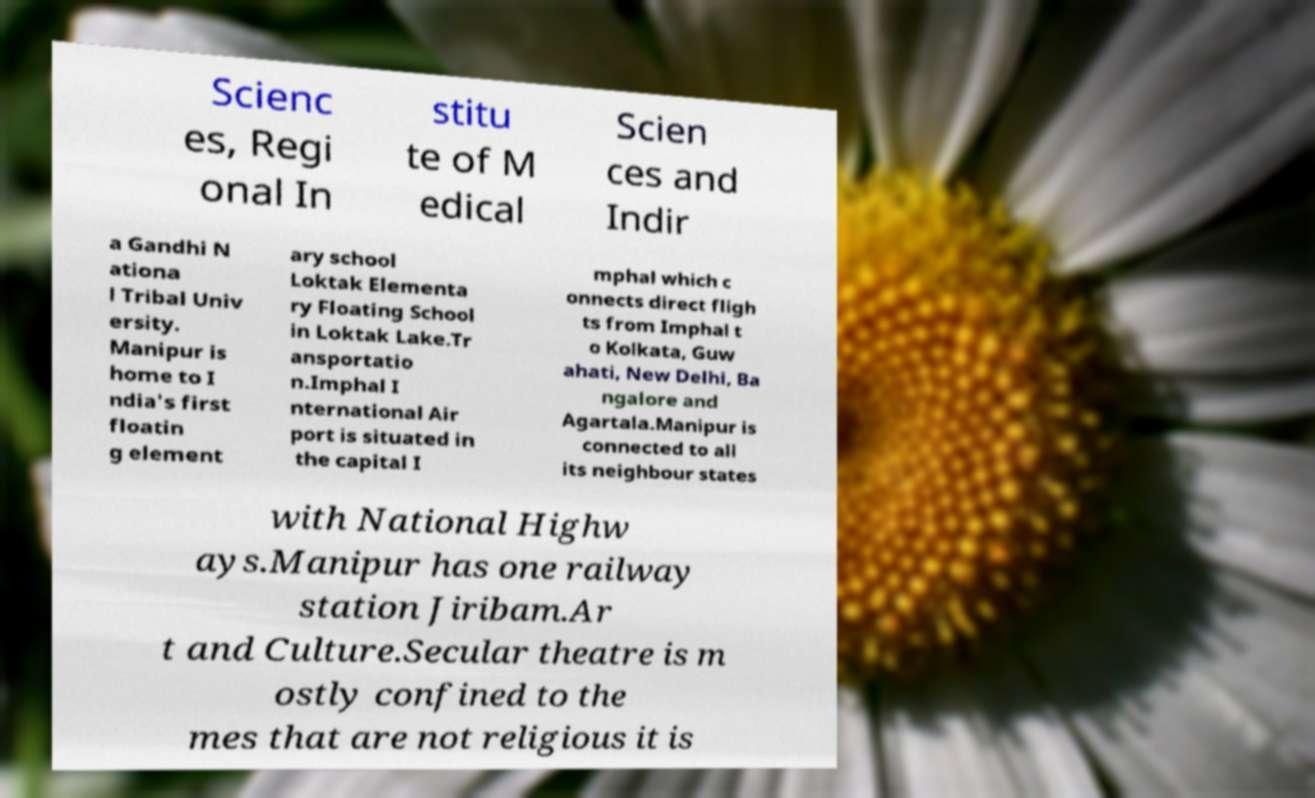Could you assist in decoding the text presented in this image and type it out clearly? Scienc es, Regi onal In stitu te of M edical Scien ces and Indir a Gandhi N ationa l Tribal Univ ersity. Manipur is home to I ndia's first floatin g element ary school Loktak Elementa ry Floating School in Loktak Lake.Tr ansportatio n.Imphal I nternational Air port is situated in the capital I mphal which c onnects direct fligh ts from Imphal t o Kolkata, Guw ahati, New Delhi, Ba ngalore and Agartala.Manipur is connected to all its neighbour states with National Highw ays.Manipur has one railway station Jiribam.Ar t and Culture.Secular theatre is m ostly confined to the mes that are not religious it is 